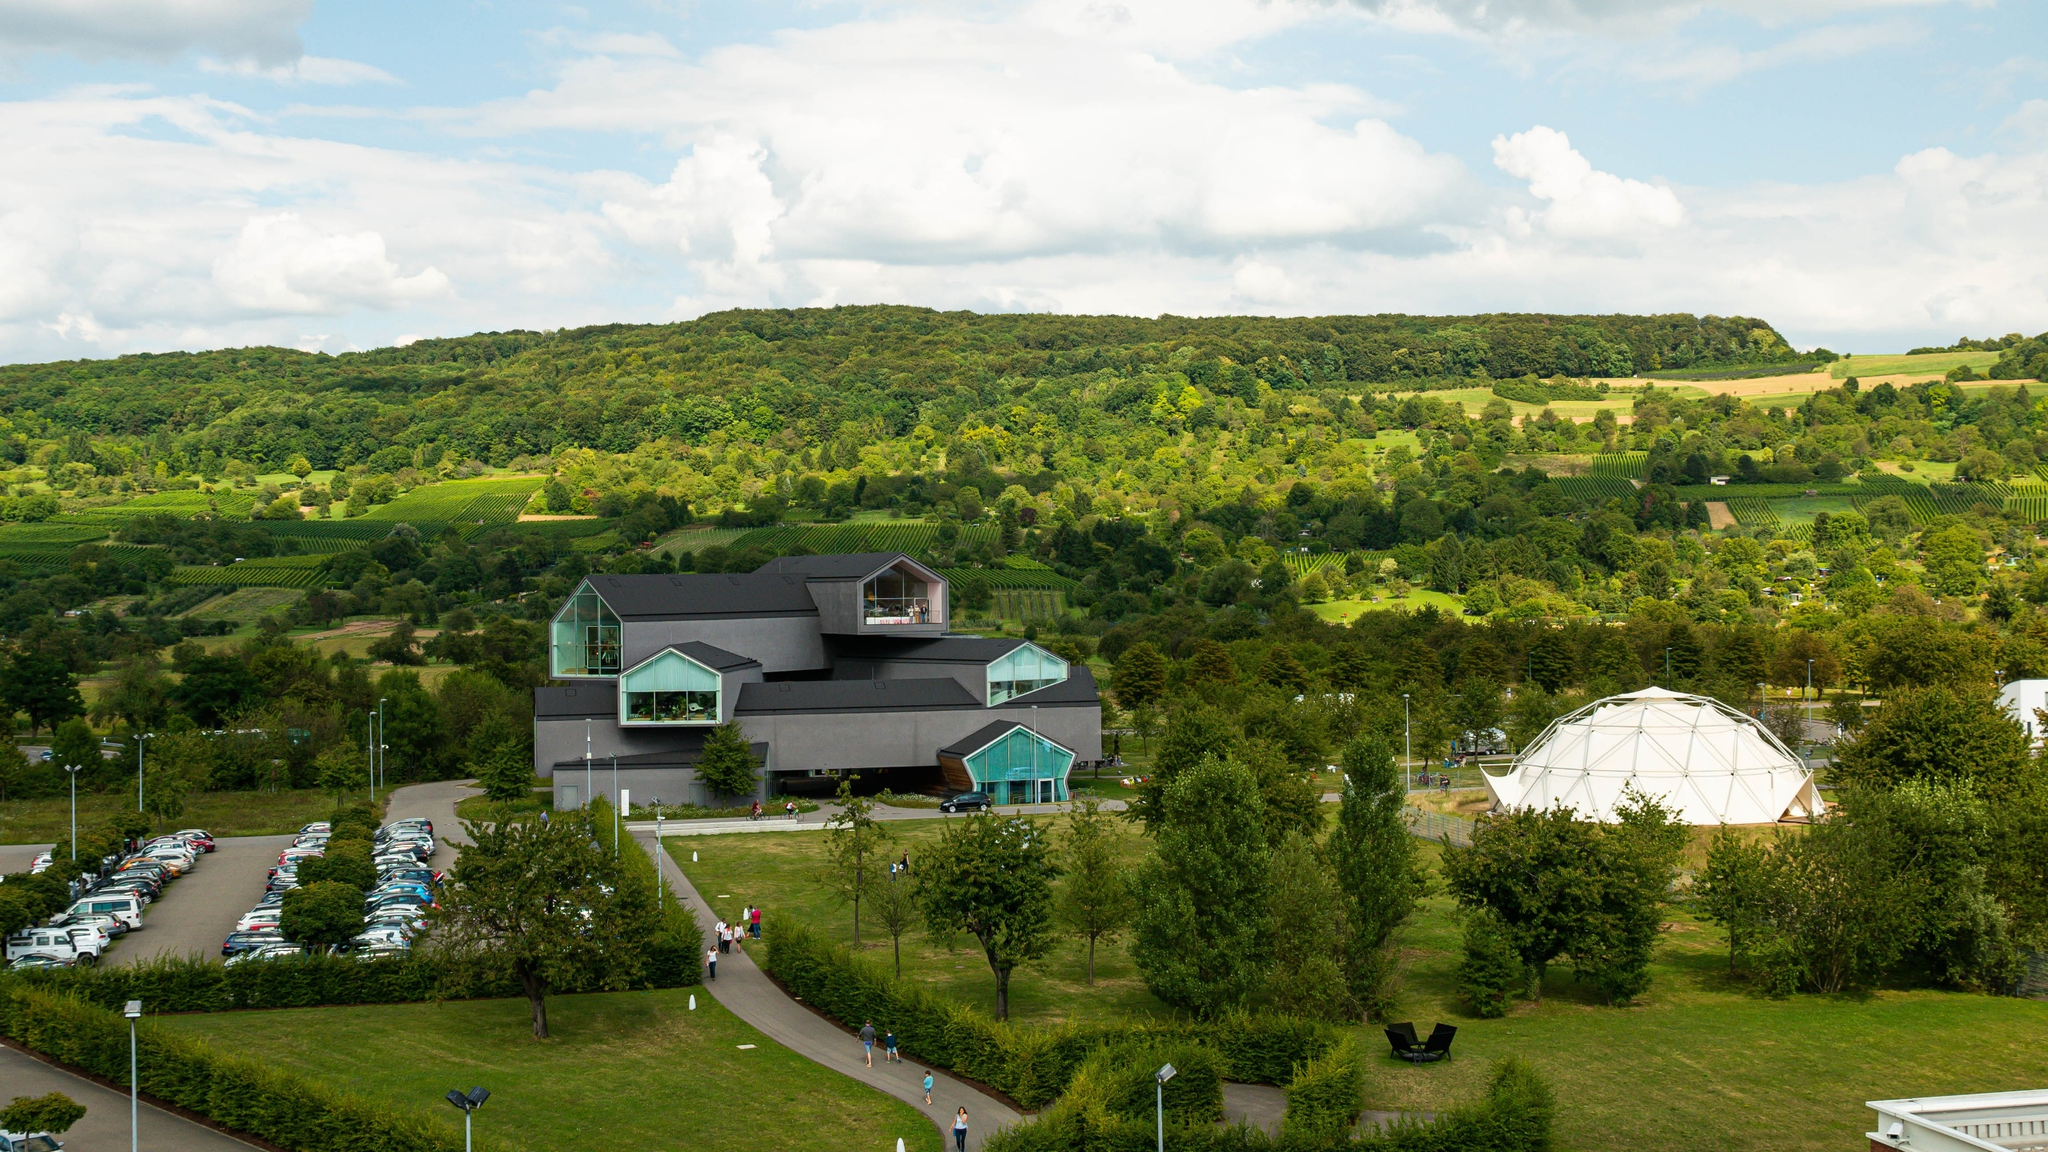Explain the visual content of the image in great detail. The image showcases the Vitra Design Museum, a stunning piece of contemporary architecture located in Weil am Rhein, Germany. The museum is notable for its sleek, black exterior and prominent triangular windows that lend it a distinctive appearance. Surrounding the museum is lush, verdant greenery, adding a natural charm to the scene. In the foreground, there's a well-maintained parking lot filled with cars, indicating easy accessibility for visitors. The elevated perspective of the photograph provides a comprehensive view of the museum and its environment, which includes rolling hills adorned with dense forests and cultivated fields. This scenic backdrop highlights the contrast between the modern design of the museum and the pristine, natural beauty of the landscape. A geodesic dome structure is also visible nearby, adding another layer of architectural interest to the scene. The image code 'sa_16349' might refer to a specific photo collection or series. 